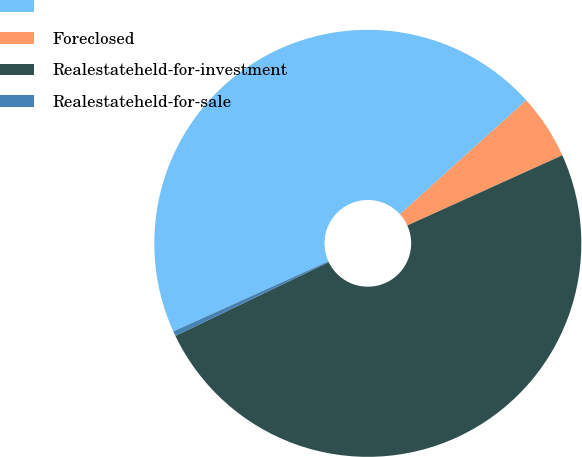Convert chart to OTSL. <chart><loc_0><loc_0><loc_500><loc_500><pie_chart><ecel><fcel>Foreclosed<fcel>Realestateheld-for-investment<fcel>Realestateheld-for-sale<nl><fcel>45.08%<fcel>4.92%<fcel>49.63%<fcel>0.37%<nl></chart> 